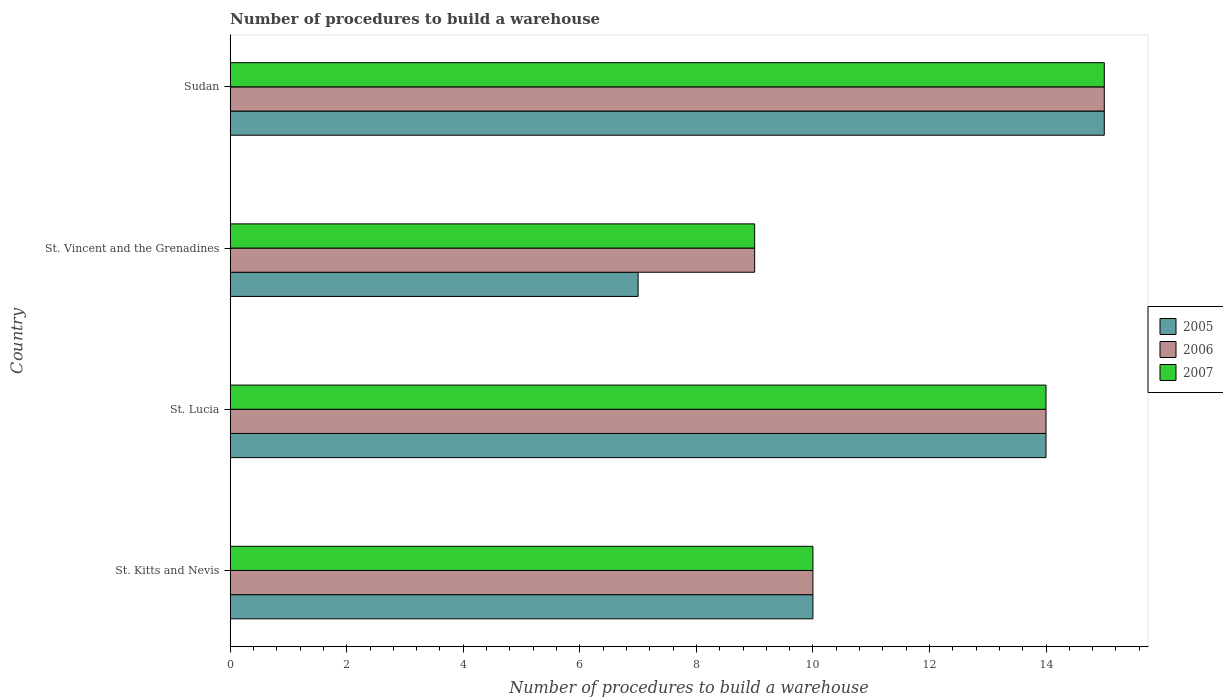How many groups of bars are there?
Make the answer very short. 4. Are the number of bars per tick equal to the number of legend labels?
Your answer should be compact. Yes. Are the number of bars on each tick of the Y-axis equal?
Ensure brevity in your answer.  Yes. What is the label of the 1st group of bars from the top?
Your answer should be compact. Sudan. In how many cases, is the number of bars for a given country not equal to the number of legend labels?
Offer a terse response. 0. What is the number of procedures to build a warehouse in in 2005 in St. Kitts and Nevis?
Make the answer very short. 10. Across all countries, what is the maximum number of procedures to build a warehouse in in 2006?
Provide a short and direct response. 15. In which country was the number of procedures to build a warehouse in in 2005 maximum?
Provide a short and direct response. Sudan. In which country was the number of procedures to build a warehouse in in 2007 minimum?
Give a very brief answer. St. Vincent and the Grenadines. What is the difference between the number of procedures to build a warehouse in in 2007 in St. Lucia and that in St. Vincent and the Grenadines?
Your response must be concise. 5. What is the difference between the number of procedures to build a warehouse in in 2007 in Sudan and the number of procedures to build a warehouse in in 2005 in St. Vincent and the Grenadines?
Ensure brevity in your answer.  8. What is the difference between the number of procedures to build a warehouse in in 2005 and number of procedures to build a warehouse in in 2007 in St. Vincent and the Grenadines?
Ensure brevity in your answer.  -2. What is the ratio of the number of procedures to build a warehouse in in 2005 in St. Vincent and the Grenadines to that in Sudan?
Offer a terse response. 0.47. Is the difference between the number of procedures to build a warehouse in in 2005 in St. Lucia and Sudan greater than the difference between the number of procedures to build a warehouse in in 2007 in St. Lucia and Sudan?
Offer a very short reply. No. What does the 2nd bar from the top in St. Lucia represents?
Your answer should be very brief. 2006. What does the 1st bar from the bottom in Sudan represents?
Keep it short and to the point. 2005. Is it the case that in every country, the sum of the number of procedures to build a warehouse in in 2006 and number of procedures to build a warehouse in in 2007 is greater than the number of procedures to build a warehouse in in 2005?
Provide a short and direct response. Yes. How many countries are there in the graph?
Provide a short and direct response. 4. What is the difference between two consecutive major ticks on the X-axis?
Your answer should be compact. 2. Are the values on the major ticks of X-axis written in scientific E-notation?
Keep it short and to the point. No. Does the graph contain grids?
Your response must be concise. No. Where does the legend appear in the graph?
Your answer should be compact. Center right. How many legend labels are there?
Provide a short and direct response. 3. What is the title of the graph?
Offer a very short reply. Number of procedures to build a warehouse. Does "1966" appear as one of the legend labels in the graph?
Your response must be concise. No. What is the label or title of the X-axis?
Offer a terse response. Number of procedures to build a warehouse. What is the Number of procedures to build a warehouse of 2005 in St. Kitts and Nevis?
Your response must be concise. 10. What is the Number of procedures to build a warehouse of 2007 in St. Kitts and Nevis?
Provide a succinct answer. 10. What is the Number of procedures to build a warehouse in 2007 in St. Lucia?
Provide a short and direct response. 14. What is the Number of procedures to build a warehouse of 2005 in St. Vincent and the Grenadines?
Keep it short and to the point. 7. What is the Number of procedures to build a warehouse in 2007 in St. Vincent and the Grenadines?
Your response must be concise. 9. What is the Number of procedures to build a warehouse of 2006 in Sudan?
Provide a short and direct response. 15. Across all countries, what is the maximum Number of procedures to build a warehouse of 2006?
Your answer should be compact. 15. Across all countries, what is the maximum Number of procedures to build a warehouse of 2007?
Make the answer very short. 15. What is the total Number of procedures to build a warehouse of 2005 in the graph?
Your answer should be compact. 46. What is the difference between the Number of procedures to build a warehouse of 2005 in St. Kitts and Nevis and that in St. Vincent and the Grenadines?
Your response must be concise. 3. What is the difference between the Number of procedures to build a warehouse of 2006 in St. Kitts and Nevis and that in Sudan?
Offer a very short reply. -5. What is the difference between the Number of procedures to build a warehouse of 2007 in St. Kitts and Nevis and that in Sudan?
Your response must be concise. -5. What is the difference between the Number of procedures to build a warehouse of 2007 in St. Lucia and that in St. Vincent and the Grenadines?
Provide a short and direct response. 5. What is the difference between the Number of procedures to build a warehouse in 2005 in St. Lucia and that in Sudan?
Your response must be concise. -1. What is the difference between the Number of procedures to build a warehouse of 2006 in St. Lucia and that in Sudan?
Offer a terse response. -1. What is the difference between the Number of procedures to build a warehouse of 2005 in St. Vincent and the Grenadines and that in Sudan?
Provide a short and direct response. -8. What is the difference between the Number of procedures to build a warehouse of 2006 in St. Vincent and the Grenadines and that in Sudan?
Give a very brief answer. -6. What is the difference between the Number of procedures to build a warehouse of 2007 in St. Vincent and the Grenadines and that in Sudan?
Provide a short and direct response. -6. What is the difference between the Number of procedures to build a warehouse of 2005 in St. Kitts and Nevis and the Number of procedures to build a warehouse of 2007 in St. Vincent and the Grenadines?
Give a very brief answer. 1. What is the difference between the Number of procedures to build a warehouse of 2005 in St. Kitts and Nevis and the Number of procedures to build a warehouse of 2007 in Sudan?
Make the answer very short. -5. What is the difference between the Number of procedures to build a warehouse in 2006 in St. Kitts and Nevis and the Number of procedures to build a warehouse in 2007 in Sudan?
Keep it short and to the point. -5. What is the difference between the Number of procedures to build a warehouse of 2005 in St. Lucia and the Number of procedures to build a warehouse of 2007 in St. Vincent and the Grenadines?
Offer a terse response. 5. What is the difference between the Number of procedures to build a warehouse of 2005 in St. Lucia and the Number of procedures to build a warehouse of 2006 in Sudan?
Offer a terse response. -1. What is the difference between the Number of procedures to build a warehouse of 2005 in St. Lucia and the Number of procedures to build a warehouse of 2007 in Sudan?
Provide a succinct answer. -1. What is the difference between the Number of procedures to build a warehouse of 2006 in St. Lucia and the Number of procedures to build a warehouse of 2007 in Sudan?
Offer a terse response. -1. What is the difference between the Number of procedures to build a warehouse in 2005 in St. Vincent and the Grenadines and the Number of procedures to build a warehouse in 2006 in Sudan?
Your answer should be very brief. -8. What is the difference between the Number of procedures to build a warehouse in 2005 in St. Vincent and the Grenadines and the Number of procedures to build a warehouse in 2007 in Sudan?
Your answer should be compact. -8. What is the average Number of procedures to build a warehouse in 2006 per country?
Your response must be concise. 12. What is the average Number of procedures to build a warehouse of 2007 per country?
Ensure brevity in your answer.  12. What is the difference between the Number of procedures to build a warehouse of 2005 and Number of procedures to build a warehouse of 2006 in St. Kitts and Nevis?
Make the answer very short. 0. What is the difference between the Number of procedures to build a warehouse of 2006 and Number of procedures to build a warehouse of 2007 in St. Kitts and Nevis?
Provide a succinct answer. 0. What is the difference between the Number of procedures to build a warehouse in 2005 and Number of procedures to build a warehouse in 2007 in St. Lucia?
Keep it short and to the point. 0. What is the difference between the Number of procedures to build a warehouse in 2006 and Number of procedures to build a warehouse in 2007 in St. Lucia?
Provide a short and direct response. 0. What is the difference between the Number of procedures to build a warehouse of 2005 and Number of procedures to build a warehouse of 2007 in Sudan?
Your answer should be compact. 0. What is the difference between the Number of procedures to build a warehouse of 2006 and Number of procedures to build a warehouse of 2007 in Sudan?
Your answer should be very brief. 0. What is the ratio of the Number of procedures to build a warehouse of 2006 in St. Kitts and Nevis to that in St. Lucia?
Give a very brief answer. 0.71. What is the ratio of the Number of procedures to build a warehouse in 2007 in St. Kitts and Nevis to that in St. Lucia?
Provide a short and direct response. 0.71. What is the ratio of the Number of procedures to build a warehouse in 2005 in St. Kitts and Nevis to that in St. Vincent and the Grenadines?
Provide a succinct answer. 1.43. What is the ratio of the Number of procedures to build a warehouse in 2006 in St. Kitts and Nevis to that in St. Vincent and the Grenadines?
Provide a short and direct response. 1.11. What is the ratio of the Number of procedures to build a warehouse in 2007 in St. Kitts and Nevis to that in St. Vincent and the Grenadines?
Offer a very short reply. 1.11. What is the ratio of the Number of procedures to build a warehouse of 2005 in St. Lucia to that in St. Vincent and the Grenadines?
Your answer should be compact. 2. What is the ratio of the Number of procedures to build a warehouse of 2006 in St. Lucia to that in St. Vincent and the Grenadines?
Offer a terse response. 1.56. What is the ratio of the Number of procedures to build a warehouse in 2007 in St. Lucia to that in St. Vincent and the Grenadines?
Provide a short and direct response. 1.56. What is the ratio of the Number of procedures to build a warehouse in 2007 in St. Lucia to that in Sudan?
Ensure brevity in your answer.  0.93. What is the ratio of the Number of procedures to build a warehouse of 2005 in St. Vincent and the Grenadines to that in Sudan?
Your answer should be very brief. 0.47. What is the ratio of the Number of procedures to build a warehouse of 2006 in St. Vincent and the Grenadines to that in Sudan?
Your response must be concise. 0.6. What is the difference between the highest and the second highest Number of procedures to build a warehouse of 2005?
Your answer should be very brief. 1. What is the difference between the highest and the second highest Number of procedures to build a warehouse in 2006?
Give a very brief answer. 1. What is the difference between the highest and the second highest Number of procedures to build a warehouse in 2007?
Ensure brevity in your answer.  1. What is the difference between the highest and the lowest Number of procedures to build a warehouse in 2005?
Keep it short and to the point. 8. What is the difference between the highest and the lowest Number of procedures to build a warehouse of 2007?
Provide a succinct answer. 6. 